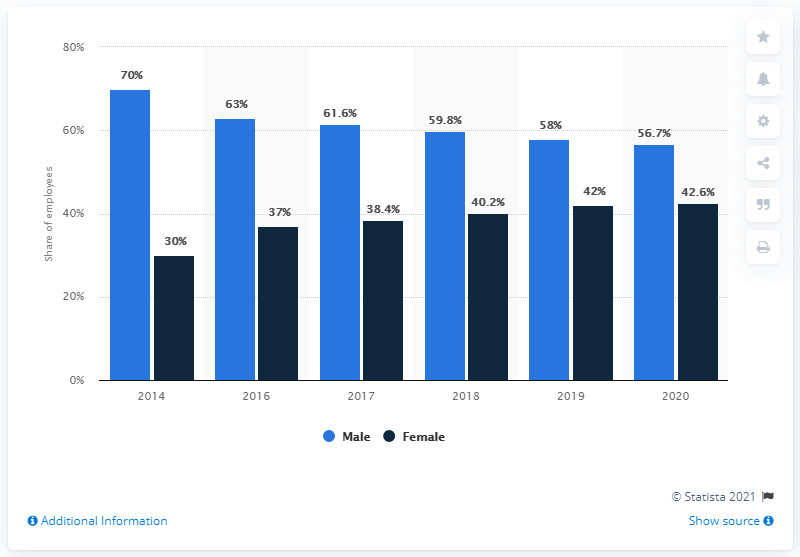What trend in gender representation do we see over the years according to this chart? The chart depicts a progressive narrowing of the gender gap in employee representation from 2014 through 2020. Initially, males comprised 70% and females 30% in 2014, but by 2020, the proportions evolved to 56.7% for males and 42.6% for females, indicating a positive trend towards gender balance in the workforce. 